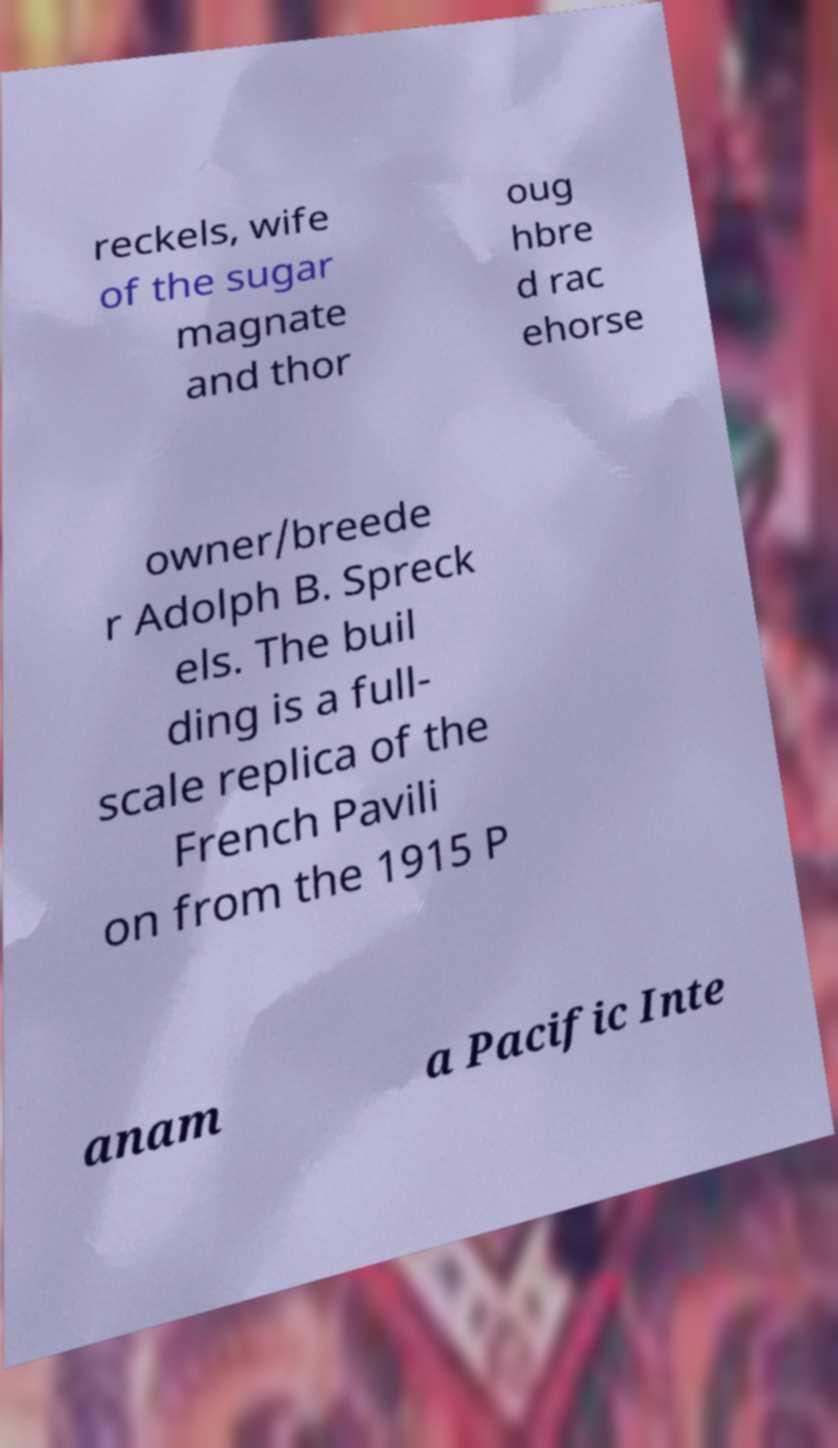Could you assist in decoding the text presented in this image and type it out clearly? reckels, wife of the sugar magnate and thor oug hbre d rac ehorse owner/breede r Adolph B. Spreck els. The buil ding is a full- scale replica of the French Pavili on from the 1915 P anam a Pacific Inte 